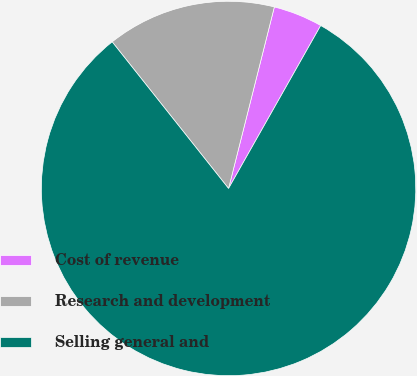Convert chart to OTSL. <chart><loc_0><loc_0><loc_500><loc_500><pie_chart><fcel>Cost of revenue<fcel>Research and development<fcel>Selling general and<nl><fcel>4.26%<fcel>14.61%<fcel>81.13%<nl></chart> 